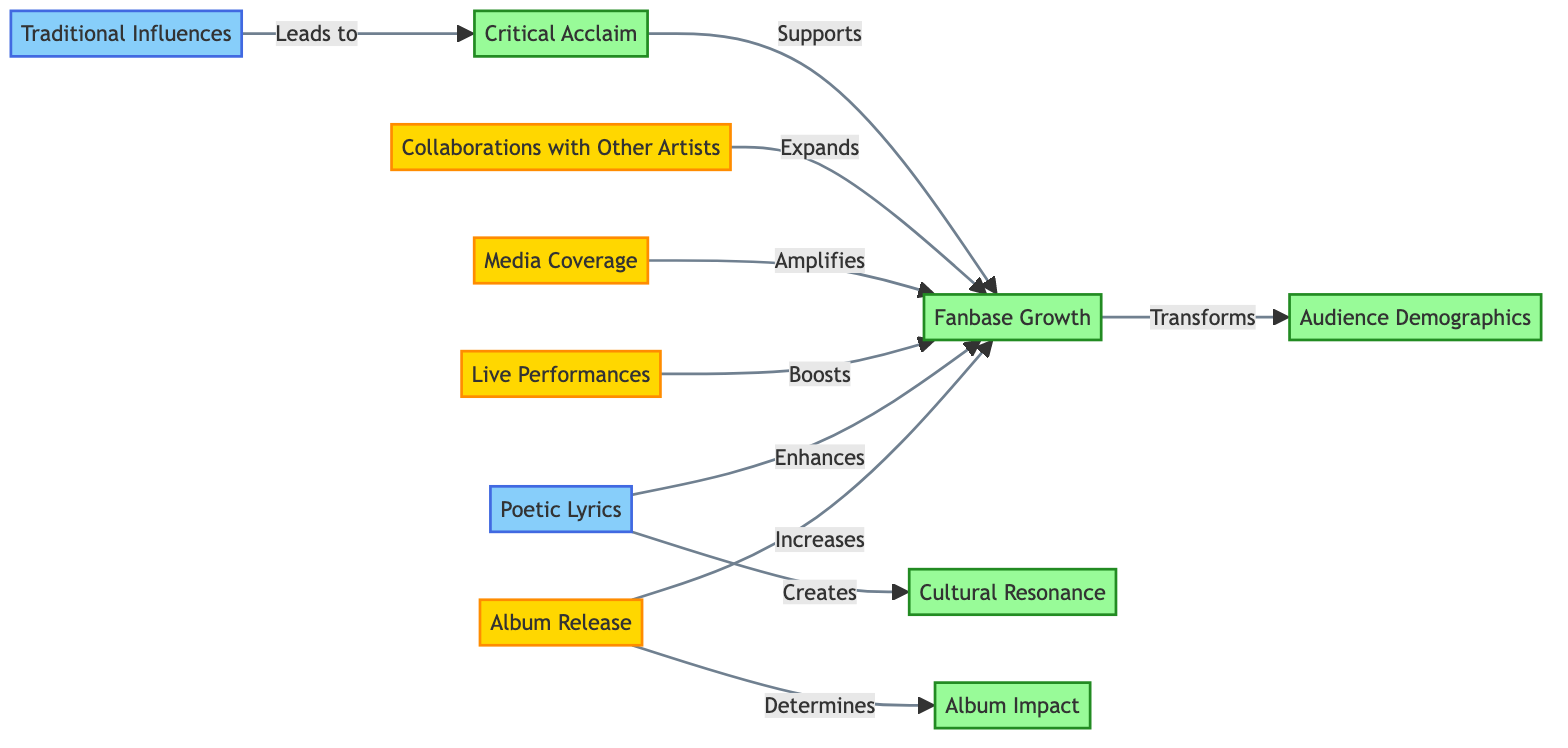What is the total number of nodes in the diagram? The diagram includes a total of 10 nodes. This is derived from counting each unique node listed in the data input.
Answer: 10 Which event directly amplifies fanbase growth? The event "Media Coverage" has a directed edge indicating that it amplifies the fanbase growth. The arrow pointing from "Media Coverage" to "Fanbase Growth" signifies this relationship.
Answer: Media Coverage What is the result of album release? The result of an album release is an increase in fanbase growth, which is represented by the directed edge from "Album Release" to "Fanbase Growth" labeled "Increases."
Answer: Fanbase Growth How do poetic lyrics influence cultural resonance? Poetic lyrics create cultural resonance, as indicated by the directed edge from "Poetic Lyrics" to "Cultural Resonance" with the label "Creates."
Answer: Creates What leads to critical acclaim in the diagram? Traditional influences lead to critical acclaim, as denoted by the directed edge from "Traditional Influences" to "Critical Acclaim" labeled "Leads to."
Answer: Traditional Influences How does fanbase growth transform audience demographics? Fanbase growth transforms audience demographics, illustrated by the directed edge from "Fanbase Growth" to "Audience Demographics" labeled "Transforms." This indicates a direct relationship between the two.
Answer: Transforms Which feature enhances fanbase growth? Poetic lyrics enhance fanbase growth, as evident from the edge going from "Poetic Lyrics" to "Fanbase Growth" labeled "Enhances." This shows the positive impact of poetic lyrics on the fanbase.
Answer: Poetic Lyrics Which event, in addition to album release, also boosts fanbase growth? Live performances boost fanbase growth, illustrated by the directed edge from "Live Performances" to "Fanbase Growth" labeled "Boosts." This indicates that both live performances and album releases contribute to increasing fanbase growth.
Answer: Live Performances What is the role of critical acclaim on fanbase growth? Critical acclaim supports fanbase growth, with the directed edge indicating that an increase in critical acclaim is beneficial for the growth of the fanbase. The edge from "Critical Acclaim" to "Fanbase Growth" is labeled "Supports."
Answer: Supports 